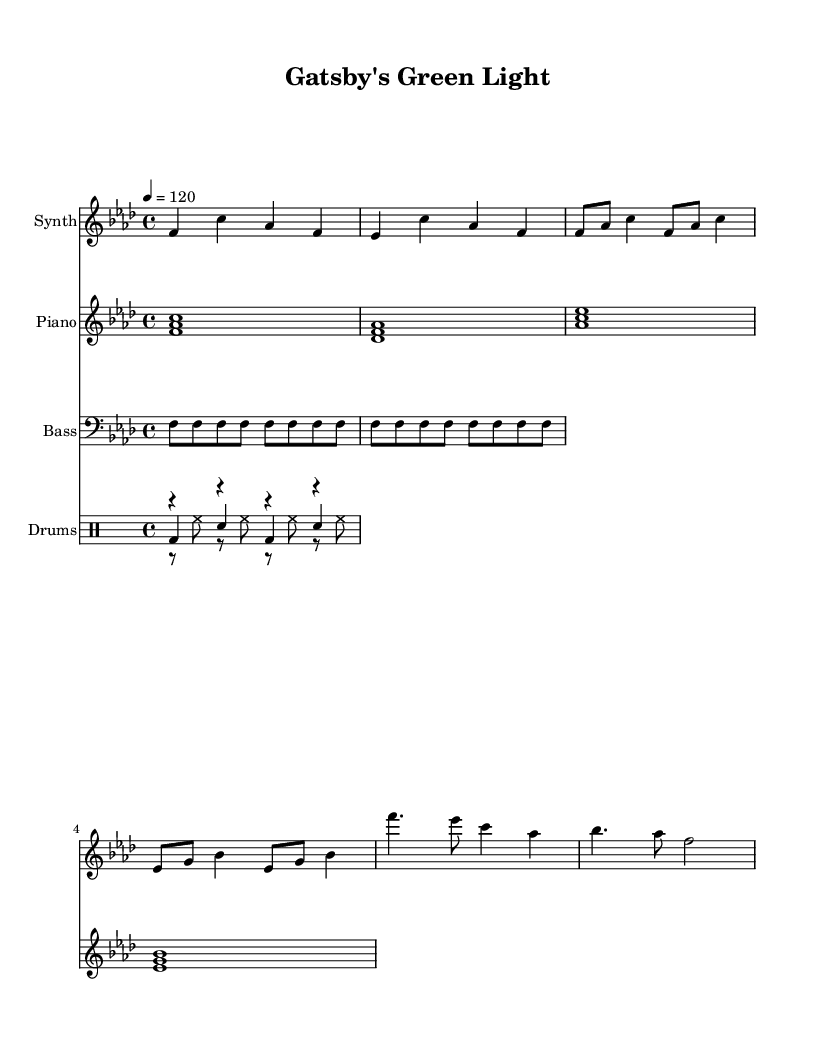What is the key signature of this music? The key signature is indicated at the beginning of the score. The presence of six flats signifies that the piece is in F minor.
Answer: F minor What is the time signature of this music? The time signature is found at the beginning of the score, shown as 4/4, meaning there are four beats per measure.
Answer: 4/4 What is the tempo marking of this piece? The tempo is indicated in the score with the marking "4 = 120", meaning there are 120 beats per minute.
Answer: 120 How many measures are in the synth melody section? The synth melody consists of a total of six measures based on the grouping of notes. Counting each measure reveals this total.
Answer: 6 What type of percussion instrument is used in the drums part? The drums part lists four standard drum components: bass drum (bd), hi-hat (hh), and snare drum (sn), which are typical for house music.
Answer: Bass drum, hi-hat, snare drum What chord is played during the chorus section? The chorus section includes the chords F major, E flat major, and A flat major based on the harmony depicted in the notation for the melody and chords.
Answer: F major What is the pattern used in the bass line? The bass line consistently plays F in a rhythmic pattern, which is indicated by the repeated notes. This establishes a steady foundation typical of house music.
Answer: Repeated F notes 